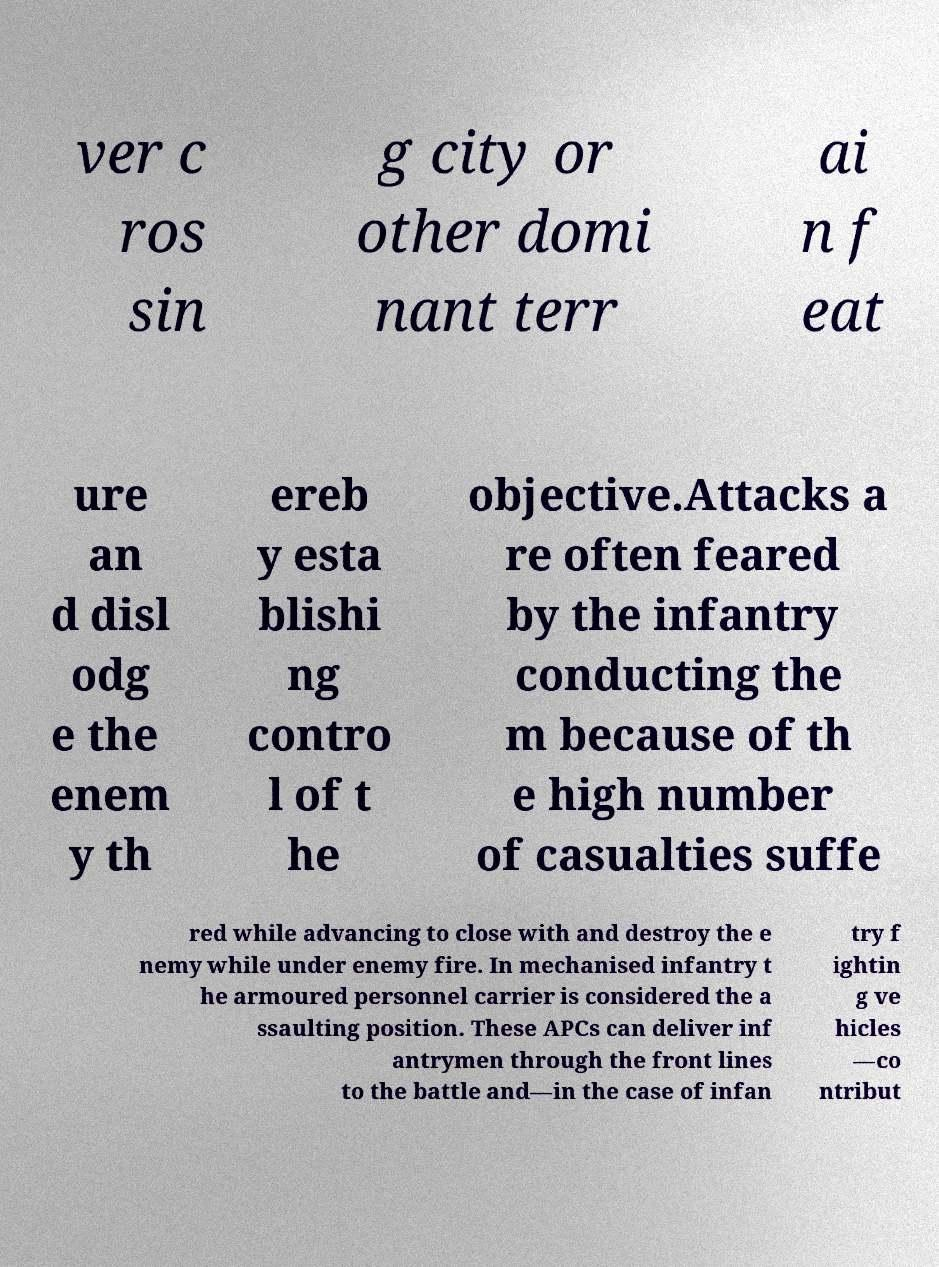Could you extract and type out the text from this image? ver c ros sin g city or other domi nant terr ai n f eat ure an d disl odg e the enem y th ereb y esta blishi ng contro l of t he objective.Attacks a re often feared by the infantry conducting the m because of th e high number of casualties suffe red while advancing to close with and destroy the e nemy while under enemy fire. In mechanised infantry t he armoured personnel carrier is considered the a ssaulting position. These APCs can deliver inf antrymen through the front lines to the battle and—in the case of infan try f ightin g ve hicles —co ntribut 